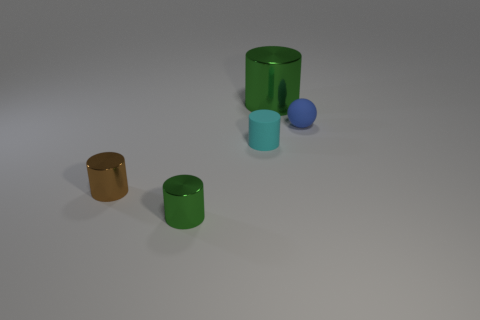Do the small cyan rubber object and the small object that is to the left of the small green cylinder have the same shape?
Keep it short and to the point. Yes. Are there any small blue objects that have the same material as the blue ball?
Keep it short and to the point. No. There is a tiny shiny object behind the green cylinder in front of the tiny brown metallic thing; are there any brown metallic cylinders that are to the right of it?
Provide a succinct answer. No. What number of other things are the same shape as the brown thing?
Your answer should be very brief. 3. What color is the tiny object left of the metallic cylinder that is in front of the small metal object that is left of the small green metal cylinder?
Keep it short and to the point. Brown. How many tiny gray cubes are there?
Ensure brevity in your answer.  0. How many tiny objects are metal cylinders or metallic cubes?
Your answer should be compact. 2. What is the shape of the brown thing that is the same size as the sphere?
Give a very brief answer. Cylinder. What is the material of the green object right of the small cylinder that is in front of the tiny brown metallic cylinder?
Your response must be concise. Metal. Do the brown cylinder and the blue matte object have the same size?
Make the answer very short. Yes. 